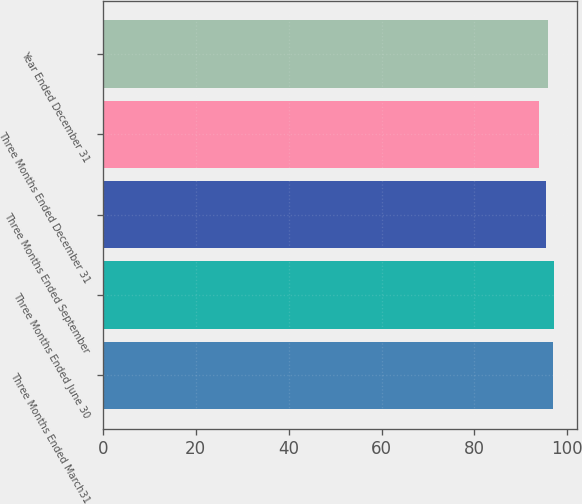Convert chart. <chart><loc_0><loc_0><loc_500><loc_500><bar_chart><fcel>Three Months Ended March31<fcel>Three Months Ended June 30<fcel>Three Months Ended September<fcel>Three Months Ended December 31<fcel>Year Ended December 31<nl><fcel>96.9<fcel>97.21<fcel>95.5<fcel>93.9<fcel>95.81<nl></chart> 